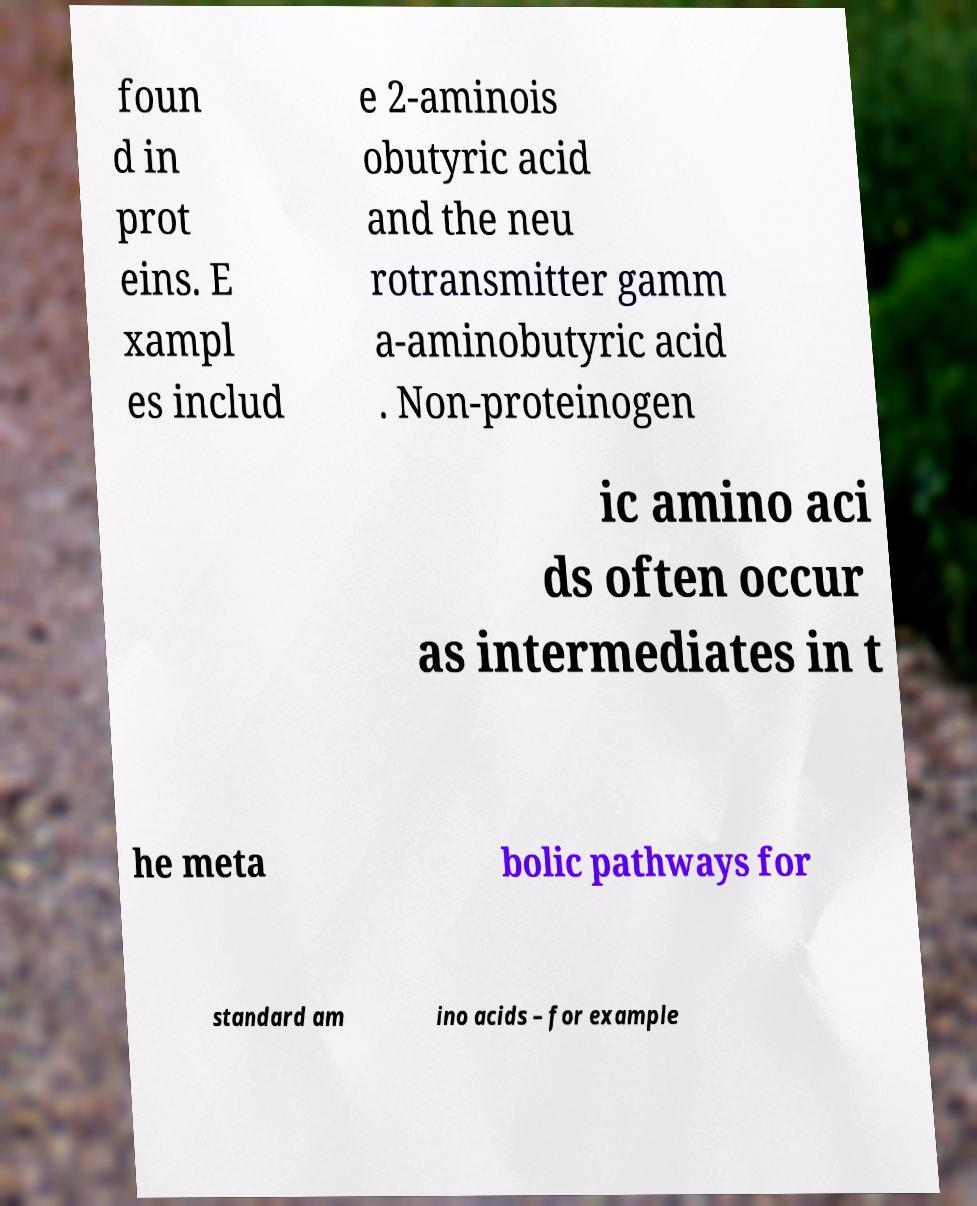Can you accurately transcribe the text from the provided image for me? foun d in prot eins. E xampl es includ e 2-aminois obutyric acid and the neu rotransmitter gamm a-aminobutyric acid . Non-proteinogen ic amino aci ds often occur as intermediates in t he meta bolic pathways for standard am ino acids – for example 